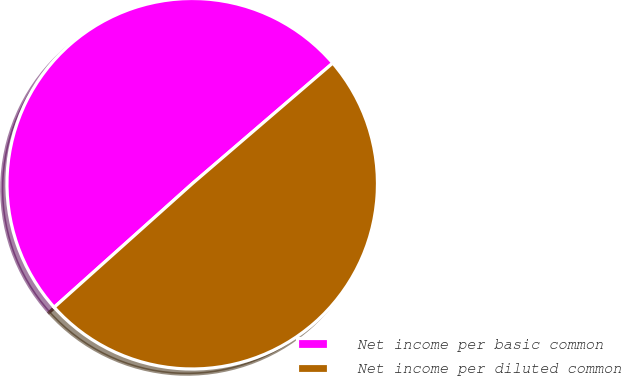Convert chart. <chart><loc_0><loc_0><loc_500><loc_500><pie_chart><fcel>Net income per basic common<fcel>Net income per diluted common<nl><fcel>50.33%<fcel>49.67%<nl></chart> 